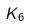Convert formula to latex. <formula><loc_0><loc_0><loc_500><loc_500>K _ { 6 }</formula> 